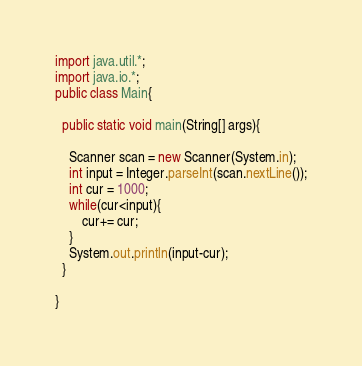<code> <loc_0><loc_0><loc_500><loc_500><_Java_>import java.util.*;
import java.io.*;
public class Main{
  
  public static void main(String[] args){
  
  	Scanner scan = new Scanner(System.in);
    int input = Integer.parseInt(scan.nextLine());
	int cur = 1000;
    while(cur<input){
    	cur+= cur;
    }
    System.out.println(input-cur);
  }
  
}</code> 